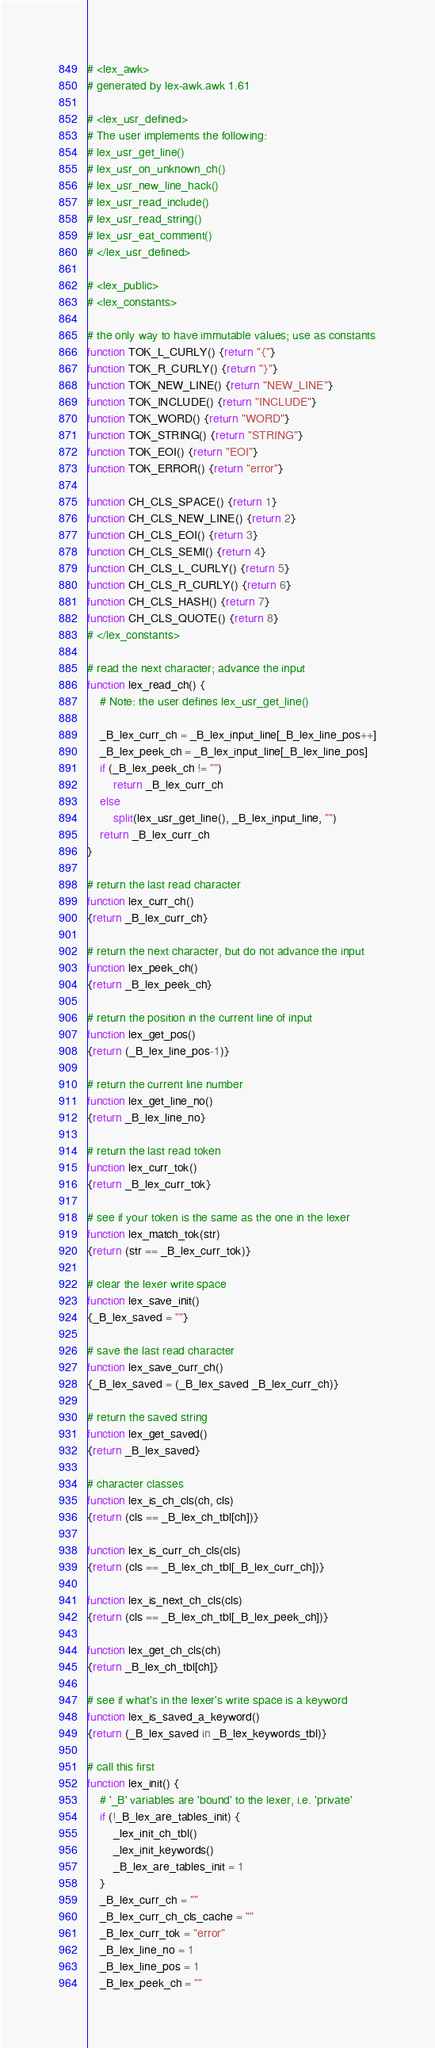<code> <loc_0><loc_0><loc_500><loc_500><_Awk_># <lex_awk>
# generated by lex-awk.awk 1.61

# <lex_usr_defined>
# The user implements the following:
# lex_usr_get_line()
# lex_usr_on_unknown_ch()
# lex_usr_new_line_hack()
# lex_usr_read_include()
# lex_usr_read_string()
# lex_usr_eat_comment()
# </lex_usr_defined>

# <lex_public>
# <lex_constants>

# the only way to have immutable values; use as constants
function TOK_L_CURLY() {return "{"}
function TOK_R_CURLY() {return "}"}
function TOK_NEW_LINE() {return "NEW_LINE"}
function TOK_INCLUDE() {return "INCLUDE"}
function TOK_WORD() {return "WORD"}
function TOK_STRING() {return "STRING"}
function TOK_EOI() {return "EOI"}
function TOK_ERROR() {return "error"}

function CH_CLS_SPACE() {return 1}
function CH_CLS_NEW_LINE() {return 2}
function CH_CLS_EOI() {return 3}
function CH_CLS_SEMI() {return 4}
function CH_CLS_L_CURLY() {return 5}
function CH_CLS_R_CURLY() {return 6}
function CH_CLS_HASH() {return 7}
function CH_CLS_QUOTE() {return 8}
# </lex_constants>

# read the next character; advance the input
function lex_read_ch() {
	# Note: the user defines lex_usr_get_line()

	_B_lex_curr_ch = _B_lex_input_line[_B_lex_line_pos++]
	_B_lex_peek_ch = _B_lex_input_line[_B_lex_line_pos]
	if (_B_lex_peek_ch != "")
		return _B_lex_curr_ch
	else
		split(lex_usr_get_line(), _B_lex_input_line, "")
	return _B_lex_curr_ch
}

# return the last read character
function lex_curr_ch()
{return _B_lex_curr_ch}

# return the next character, but do not advance the input
function lex_peek_ch()
{return _B_lex_peek_ch}

# return the position in the current line of input
function lex_get_pos()
{return (_B_lex_line_pos-1)}

# return the current line number
function lex_get_line_no()
{return _B_lex_line_no}

# return the last read token
function lex_curr_tok()
{return _B_lex_curr_tok}

# see if your token is the same as the one in the lexer
function lex_match_tok(str)
{return (str == _B_lex_curr_tok)}

# clear the lexer write space
function lex_save_init()
{_B_lex_saved = ""}

# save the last read character
function lex_save_curr_ch()
{_B_lex_saved = (_B_lex_saved _B_lex_curr_ch)}

# return the saved string
function lex_get_saved()
{return _B_lex_saved}

# character classes
function lex_is_ch_cls(ch, cls)
{return (cls == _B_lex_ch_tbl[ch])}

function lex_is_curr_ch_cls(cls)
{return (cls == _B_lex_ch_tbl[_B_lex_curr_ch])}

function lex_is_next_ch_cls(cls)
{return (cls == _B_lex_ch_tbl[_B_lex_peek_ch])}

function lex_get_ch_cls(ch)
{return _B_lex_ch_tbl[ch]}

# see if what's in the lexer's write space is a keyword
function lex_is_saved_a_keyword()
{return (_B_lex_saved in _B_lex_keywords_tbl)}

# call this first
function lex_init() {
	# '_B' variables are 'bound' to the lexer, i.e. 'private'
	if (!_B_lex_are_tables_init) {
		_lex_init_ch_tbl()
		_lex_init_keywords()
		_B_lex_are_tables_init = 1
	}
	_B_lex_curr_ch = ""
	_B_lex_curr_ch_cls_cache = ""
	_B_lex_curr_tok = "error"
	_B_lex_line_no = 1
	_B_lex_line_pos = 1
	_B_lex_peek_ch = ""</code> 